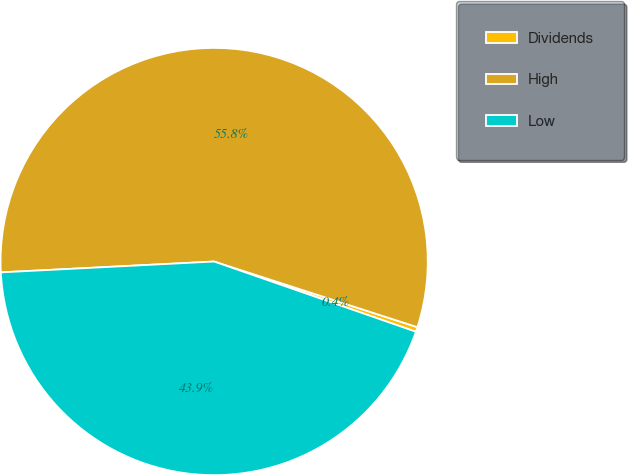Convert chart to OTSL. <chart><loc_0><loc_0><loc_500><loc_500><pie_chart><fcel>Dividends<fcel>High<fcel>Low<nl><fcel>0.36%<fcel>55.78%<fcel>43.86%<nl></chart> 